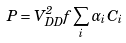<formula> <loc_0><loc_0><loc_500><loc_500>P = V _ { D D } ^ { 2 } f \sum _ { i } \alpha _ { i } C _ { i }</formula> 